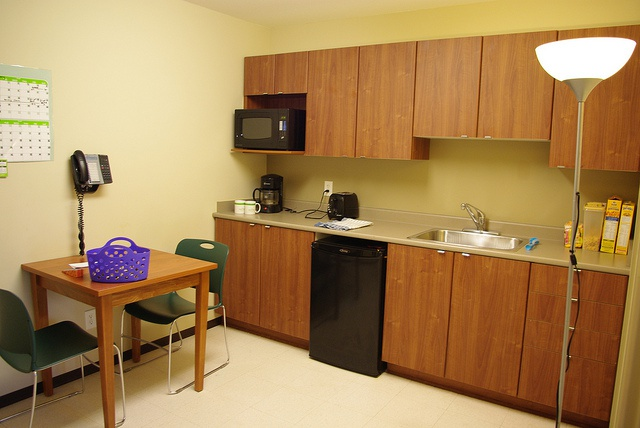Describe the objects in this image and their specific colors. I can see dining table in tan, brown, maroon, orange, and darkblue tones, refrigerator in tan, black, brown, and maroon tones, chair in tan, black, and olive tones, chair in tan, black, and gray tones, and microwave in tan, black, olive, maroon, and brown tones in this image. 